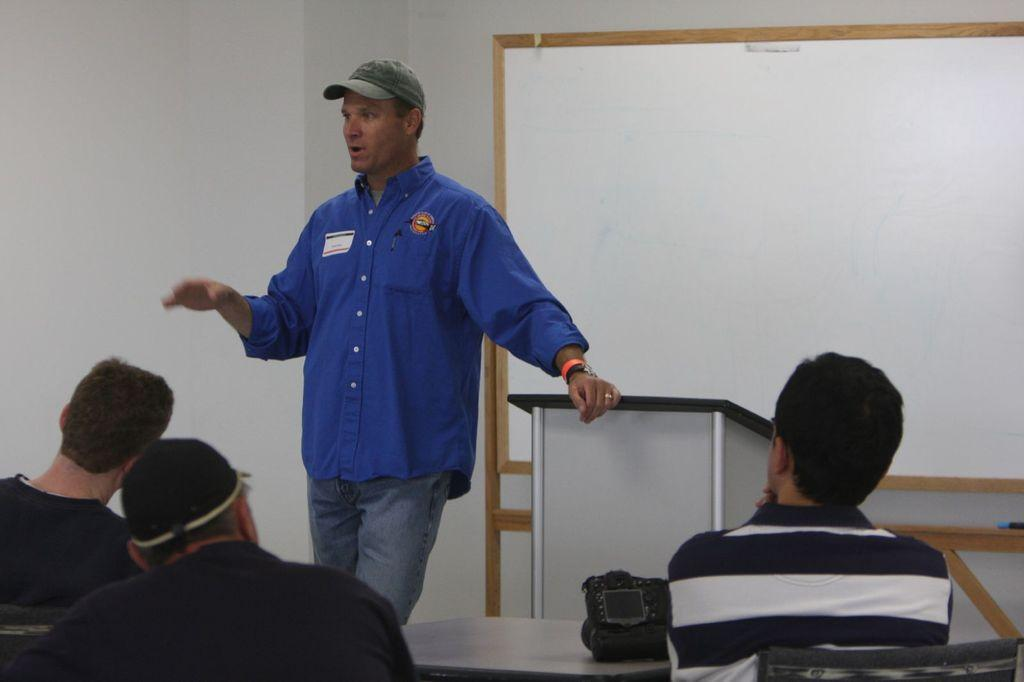What are the people in the image doing? The people in the image are sitting on a bench. What is the man near the podium doing? The man is standing near a podium. Can you describe the man's appearance? The man is wearing a cap. What is present in the image that might be used for writing or displaying information? There is a whiteboard in the image. What color is the wall visible in the image? The wall in the image is white-colored. What type of creature is crawling on the whiteboard in the image? There is no creature crawling on the whiteboard in the image. How many snakes can be seen slithering on the bench in the image? There are no snakes present in the image. --- Facts: 1. There is a car in the image. 2. The car is red. 3. The car has four wheels. 4. There is a road in the image. 5. The road is paved. Absurd Topics: parrot, ocean, dance Conversation: What is the main subject of the image? The main subject of the image is a car. Can you describe the car's appearance? The car is red and has four wheels. What is the surface of the road in the image? The road is paved. Reasoning: Let's think step by step in order to produce the conversation. We start by identifying the main subject of the image, which is the car. Then, we describe the car's appearance, focusing on its color and the number of wheels. Finally, we mention the road and its surface, providing additional context about the setting of the image. Absurd Question/Answer: Can you tell me how many parrots are sitting on the car's roof in the image? There are no parrots present in the image. What type of dance is being performed on the paved road in the image? There is no dance being performed in the image; it only features a red car on a paved road. 